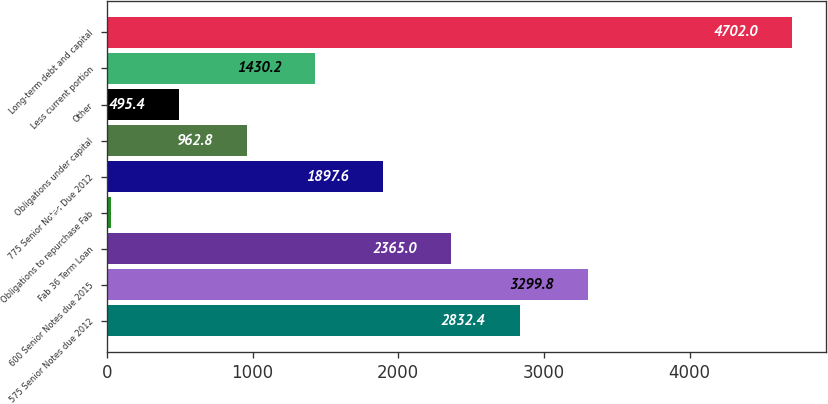<chart> <loc_0><loc_0><loc_500><loc_500><bar_chart><fcel>575 Senior Notes due 2012<fcel>600 Senior Notes due 2015<fcel>Fab 36 Term Loan<fcel>Obligations to repurchase Fab<fcel>775 Senior Notes Due 2012<fcel>Obligations under capital<fcel>Other<fcel>Less current portion<fcel>Long-term debt and capital<nl><fcel>2832.4<fcel>3299.8<fcel>2365<fcel>28<fcel>1897.6<fcel>962.8<fcel>495.4<fcel>1430.2<fcel>4702<nl></chart> 